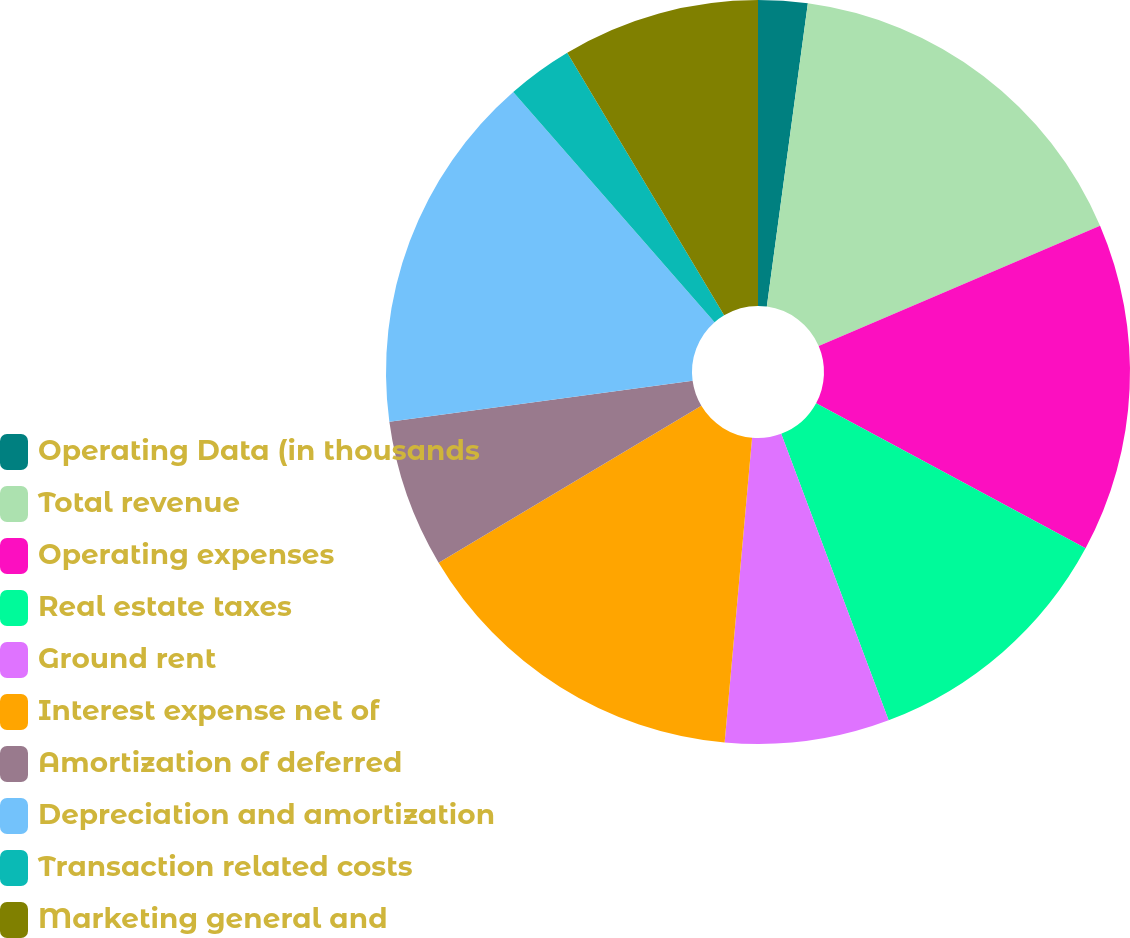Convert chart to OTSL. <chart><loc_0><loc_0><loc_500><loc_500><pie_chart><fcel>Operating Data (in thousands<fcel>Total revenue<fcel>Operating expenses<fcel>Real estate taxes<fcel>Ground rent<fcel>Interest expense net of<fcel>Amortization of deferred<fcel>Depreciation and amortization<fcel>Transaction related costs<fcel>Marketing general and<nl><fcel>2.14%<fcel>16.43%<fcel>14.29%<fcel>11.43%<fcel>7.14%<fcel>15.0%<fcel>6.43%<fcel>15.71%<fcel>2.86%<fcel>8.57%<nl></chart> 